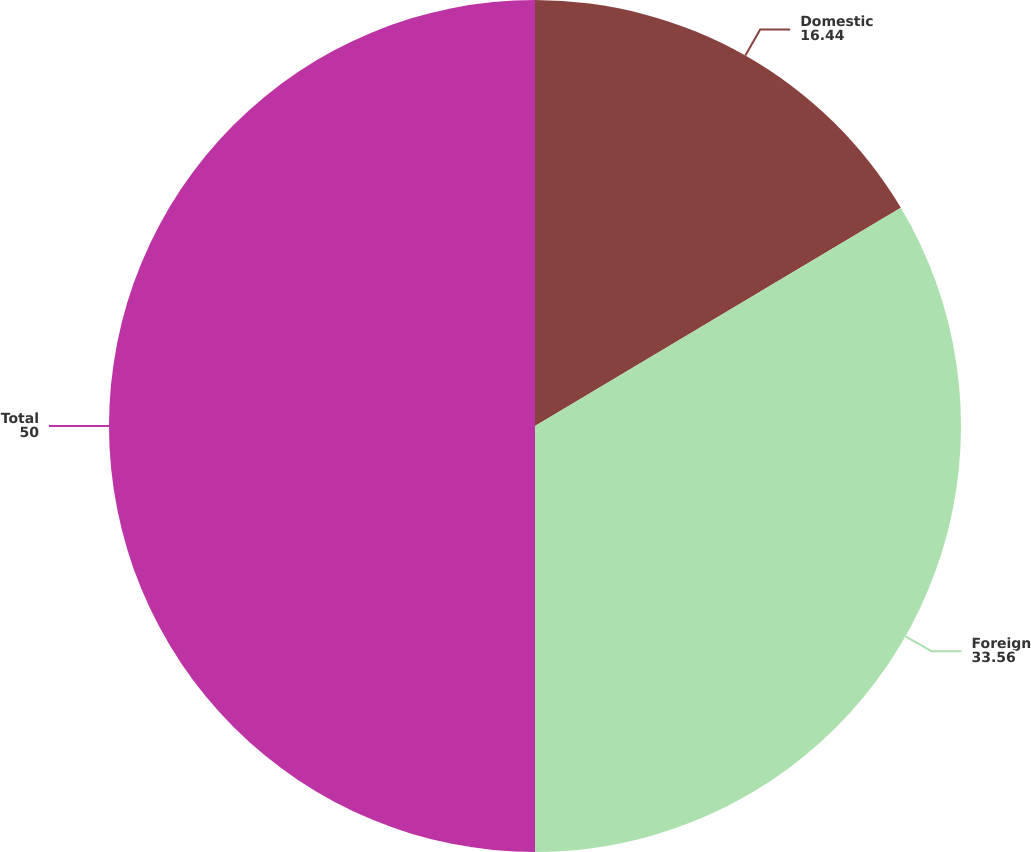Convert chart. <chart><loc_0><loc_0><loc_500><loc_500><pie_chart><fcel>Domestic<fcel>Foreign<fcel>Total<nl><fcel>16.44%<fcel>33.56%<fcel>50.0%<nl></chart> 